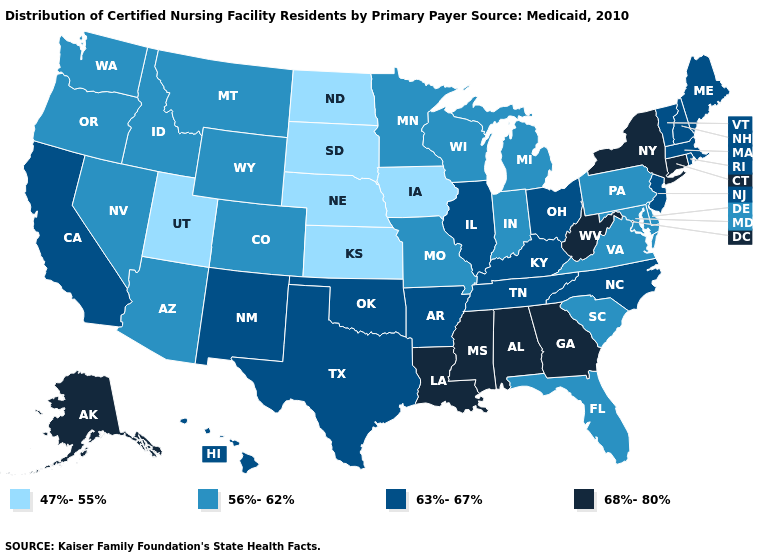Name the states that have a value in the range 56%-62%?
Keep it brief. Arizona, Colorado, Delaware, Florida, Idaho, Indiana, Maryland, Michigan, Minnesota, Missouri, Montana, Nevada, Oregon, Pennsylvania, South Carolina, Virginia, Washington, Wisconsin, Wyoming. Does New Hampshire have the same value as Alaska?
Be succinct. No. Does Florida have a higher value than Missouri?
Short answer required. No. Among the states that border Texas , which have the lowest value?
Quick response, please. Arkansas, New Mexico, Oklahoma. Does the map have missing data?
Keep it brief. No. Does Delaware have a lower value than Pennsylvania?
Concise answer only. No. What is the value of New Jersey?
Be succinct. 63%-67%. Does Utah have the lowest value in the West?
Write a very short answer. Yes. Which states have the highest value in the USA?
Short answer required. Alabama, Alaska, Connecticut, Georgia, Louisiana, Mississippi, New York, West Virginia. Does Kentucky have the lowest value in the South?
Answer briefly. No. Name the states that have a value in the range 68%-80%?
Be succinct. Alabama, Alaska, Connecticut, Georgia, Louisiana, Mississippi, New York, West Virginia. Which states hav the highest value in the South?
Short answer required. Alabama, Georgia, Louisiana, Mississippi, West Virginia. Does North Carolina have the highest value in the South?
Short answer required. No. What is the value of Ohio?
Write a very short answer. 63%-67%. What is the highest value in the South ?
Short answer required. 68%-80%. 